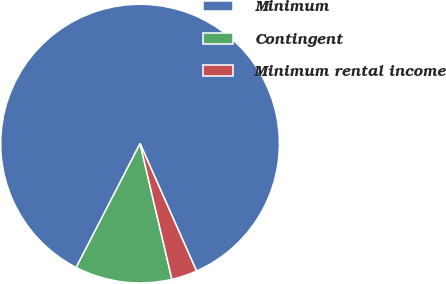<chart> <loc_0><loc_0><loc_500><loc_500><pie_chart><fcel>Minimum<fcel>Contingent<fcel>Minimum rental income<nl><fcel>85.79%<fcel>11.25%<fcel>2.97%<nl></chart> 